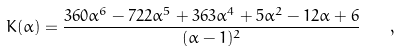<formula> <loc_0><loc_0><loc_500><loc_500>K ( \alpha ) = \frac { 3 6 0 \alpha ^ { 6 } - 7 2 2 \alpha ^ { 5 } + 3 6 3 \alpha ^ { 4 } + 5 \alpha ^ { 2 } - 1 2 \alpha + 6 } { ( \alpha - 1 ) ^ { 2 } } \quad ,</formula> 